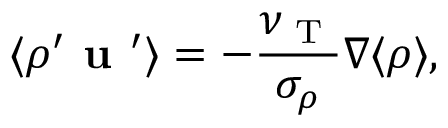<formula> <loc_0><loc_0><loc_500><loc_500>\langle { \rho ^ { \prime } { u } ^ { \prime } } \rangle = - \frac { \nu _ { T } } { \sigma _ { \rho } } { \nabla } \langle { \rho } \rangle ,</formula> 